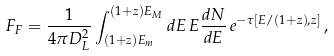<formula> <loc_0><loc_0><loc_500><loc_500>F _ { F } = \frac { 1 } { 4 \pi D _ { L } ^ { 2 } } \int ^ { ( 1 + z ) E _ { M } } _ { ( 1 + z ) E _ { m } } d E \, E \frac { d N } { d E } \, e ^ { - \tau [ E / ( 1 + z ) , z ] } \, ,</formula> 